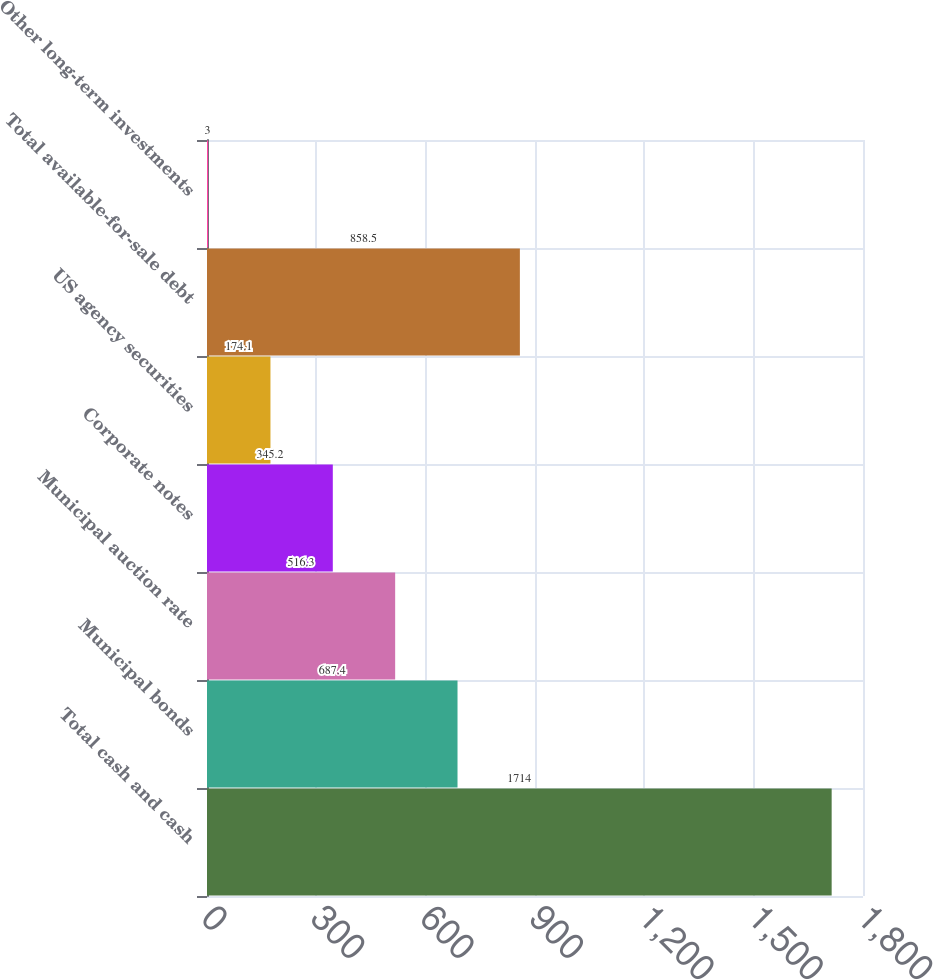<chart> <loc_0><loc_0><loc_500><loc_500><bar_chart><fcel>Total cash and cash<fcel>Municipal bonds<fcel>Municipal auction rate<fcel>Corporate notes<fcel>US agency securities<fcel>Total available-for-sale debt<fcel>Other long-term investments<nl><fcel>1714<fcel>687.4<fcel>516.3<fcel>345.2<fcel>174.1<fcel>858.5<fcel>3<nl></chart> 